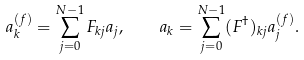<formula> <loc_0><loc_0><loc_500><loc_500>a _ { k } ^ { ( f ) } = \sum _ { j = 0 } ^ { N - 1 } F _ { k j } a _ { j } , \quad a _ { k } = \sum _ { j = 0 } ^ { N - 1 } ( F ^ { \dagger } ) _ { k j } a _ { j } ^ { ( f ) } .</formula> 